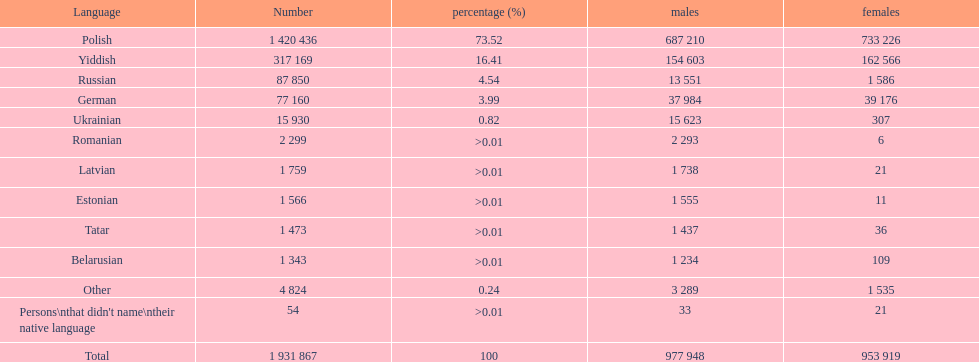Which language had the most number of people speaking it. Polish. 